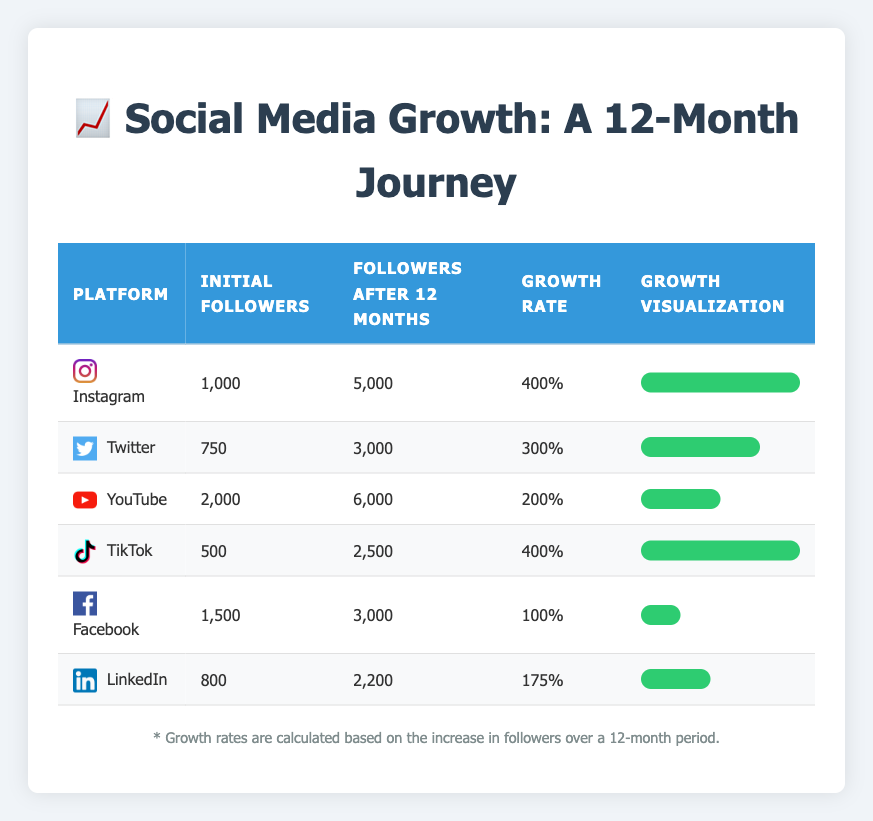What is the growth rate for TikTok? The growth rate for TikTok is listed directly in the table under the "Growth Rate" column. For TikTok, the value is 400%.
Answer: 400% Which platform has the highest initial followers? By comparing the "Initial Followers" column across all platforms, YouTube has the highest initial followers with a count of 2,000.
Answer: YouTube What is the combined growth rate of Facebook and LinkedIn? To find the combined growth rate, we add the growth rates of Facebook (100%) and LinkedIn (175%). So, 100 + 175 = 275%.
Answer: 275% Is the growth rate for Instagram greater than that of YouTube? The growth rate for Instagram is 400%, while YouTube's growth rate is 200%. Since 400% is greater than 200%, the statement is true.
Answer: Yes What is the difference in follower count after 12 months between Twitter and TikTok? From the table, Twitter has 3,000 followers after 12 months, and TikTok has 2,500. The difference is 3,000 - 2,500 = 500.
Answer: 500 Which platform had the lowest growth rate? By looking at the "Growth Rate" column, Facebook has the lowest growth rate with a value of 100%.
Answer: Facebook Calculate the average initial followers across these platforms. Adding the initial followers: 1000 (Instagram) + 750 (Twitter) + 2000 (YouTube) + 500 (TikTok) + 1500 (Facebook) + 800 (LinkedIn) gives a total of 5,550. Dividing by the number of platforms (6) equals 925.
Answer: 925 Which platform experienced a growth rate of 300%? Looking through the "Growth Rate" column, the platform with a growth rate of 300% is Twitter.
Answer: Twitter What is the total number of followers after 12 months across all platforms? Adding the followers after 12 months gives: 5000 (Instagram) + 3000 (Twitter) + 6000 (YouTube) + 2500 (TikTok) + 3000 (Facebook) + 2200 (LinkedIn) which sums up to 21,700.
Answer: 21,700 